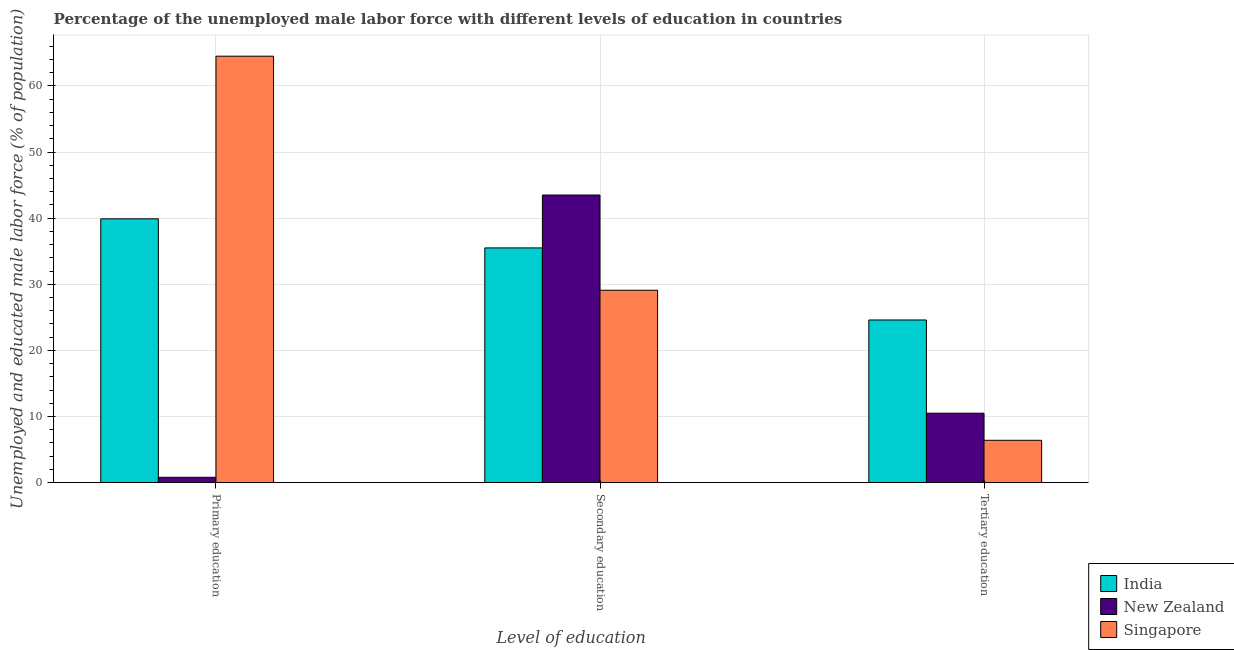How many groups of bars are there?
Provide a short and direct response. 3. Are the number of bars on each tick of the X-axis equal?
Ensure brevity in your answer.  Yes. How many bars are there on the 1st tick from the right?
Give a very brief answer. 3. What is the label of the 3rd group of bars from the left?
Your answer should be compact. Tertiary education. What is the percentage of male labor force who received primary education in New Zealand?
Provide a succinct answer. 0.8. Across all countries, what is the maximum percentage of male labor force who received secondary education?
Make the answer very short. 43.5. Across all countries, what is the minimum percentage of male labor force who received secondary education?
Ensure brevity in your answer.  29.1. In which country was the percentage of male labor force who received tertiary education maximum?
Give a very brief answer. India. In which country was the percentage of male labor force who received secondary education minimum?
Offer a very short reply. Singapore. What is the total percentage of male labor force who received primary education in the graph?
Make the answer very short. 105.2. What is the difference between the percentage of male labor force who received primary education in India and that in Singapore?
Offer a terse response. -24.6. What is the difference between the percentage of male labor force who received tertiary education in India and the percentage of male labor force who received primary education in Singapore?
Provide a short and direct response. -39.9. What is the average percentage of male labor force who received tertiary education per country?
Offer a very short reply. 13.83. What is the difference between the percentage of male labor force who received tertiary education and percentage of male labor force who received primary education in India?
Your answer should be very brief. -15.3. What is the ratio of the percentage of male labor force who received primary education in India to that in New Zealand?
Offer a terse response. 49.88. Is the difference between the percentage of male labor force who received secondary education in Singapore and New Zealand greater than the difference between the percentage of male labor force who received tertiary education in Singapore and New Zealand?
Your answer should be very brief. No. What is the difference between the highest and the second highest percentage of male labor force who received primary education?
Ensure brevity in your answer.  24.6. What is the difference between the highest and the lowest percentage of male labor force who received tertiary education?
Your answer should be compact. 18.2. In how many countries, is the percentage of male labor force who received tertiary education greater than the average percentage of male labor force who received tertiary education taken over all countries?
Offer a very short reply. 1. Is the sum of the percentage of male labor force who received secondary education in New Zealand and Singapore greater than the maximum percentage of male labor force who received primary education across all countries?
Your answer should be compact. Yes. What does the 3rd bar from the right in Secondary education represents?
Keep it short and to the point. India. How many bars are there?
Give a very brief answer. 9. Are all the bars in the graph horizontal?
Your answer should be compact. No. What is the difference between two consecutive major ticks on the Y-axis?
Offer a terse response. 10. Where does the legend appear in the graph?
Your response must be concise. Bottom right. How many legend labels are there?
Offer a very short reply. 3. How are the legend labels stacked?
Keep it short and to the point. Vertical. What is the title of the graph?
Your answer should be compact. Percentage of the unemployed male labor force with different levels of education in countries. What is the label or title of the X-axis?
Your answer should be very brief. Level of education. What is the label or title of the Y-axis?
Make the answer very short. Unemployed and educated male labor force (% of population). What is the Unemployed and educated male labor force (% of population) in India in Primary education?
Ensure brevity in your answer.  39.9. What is the Unemployed and educated male labor force (% of population) in New Zealand in Primary education?
Your answer should be compact. 0.8. What is the Unemployed and educated male labor force (% of population) of Singapore in Primary education?
Your answer should be very brief. 64.5. What is the Unemployed and educated male labor force (% of population) of India in Secondary education?
Your response must be concise. 35.5. What is the Unemployed and educated male labor force (% of population) of New Zealand in Secondary education?
Provide a succinct answer. 43.5. What is the Unemployed and educated male labor force (% of population) of Singapore in Secondary education?
Provide a short and direct response. 29.1. What is the Unemployed and educated male labor force (% of population) of India in Tertiary education?
Make the answer very short. 24.6. What is the Unemployed and educated male labor force (% of population) of New Zealand in Tertiary education?
Offer a terse response. 10.5. What is the Unemployed and educated male labor force (% of population) in Singapore in Tertiary education?
Your answer should be compact. 6.4. Across all Level of education, what is the maximum Unemployed and educated male labor force (% of population) in India?
Offer a very short reply. 39.9. Across all Level of education, what is the maximum Unemployed and educated male labor force (% of population) in New Zealand?
Offer a very short reply. 43.5. Across all Level of education, what is the maximum Unemployed and educated male labor force (% of population) of Singapore?
Your answer should be very brief. 64.5. Across all Level of education, what is the minimum Unemployed and educated male labor force (% of population) in India?
Offer a terse response. 24.6. Across all Level of education, what is the minimum Unemployed and educated male labor force (% of population) in New Zealand?
Your answer should be very brief. 0.8. Across all Level of education, what is the minimum Unemployed and educated male labor force (% of population) of Singapore?
Ensure brevity in your answer.  6.4. What is the total Unemployed and educated male labor force (% of population) of India in the graph?
Offer a terse response. 100. What is the total Unemployed and educated male labor force (% of population) of New Zealand in the graph?
Keep it short and to the point. 54.8. What is the difference between the Unemployed and educated male labor force (% of population) in India in Primary education and that in Secondary education?
Make the answer very short. 4.4. What is the difference between the Unemployed and educated male labor force (% of population) in New Zealand in Primary education and that in Secondary education?
Provide a short and direct response. -42.7. What is the difference between the Unemployed and educated male labor force (% of population) of Singapore in Primary education and that in Secondary education?
Offer a very short reply. 35.4. What is the difference between the Unemployed and educated male labor force (% of population) in India in Primary education and that in Tertiary education?
Offer a terse response. 15.3. What is the difference between the Unemployed and educated male labor force (% of population) in New Zealand in Primary education and that in Tertiary education?
Your answer should be very brief. -9.7. What is the difference between the Unemployed and educated male labor force (% of population) of Singapore in Primary education and that in Tertiary education?
Your answer should be compact. 58.1. What is the difference between the Unemployed and educated male labor force (% of population) in India in Secondary education and that in Tertiary education?
Provide a succinct answer. 10.9. What is the difference between the Unemployed and educated male labor force (% of population) of Singapore in Secondary education and that in Tertiary education?
Offer a very short reply. 22.7. What is the difference between the Unemployed and educated male labor force (% of population) of India in Primary education and the Unemployed and educated male labor force (% of population) of Singapore in Secondary education?
Your answer should be very brief. 10.8. What is the difference between the Unemployed and educated male labor force (% of population) in New Zealand in Primary education and the Unemployed and educated male labor force (% of population) in Singapore in Secondary education?
Keep it short and to the point. -28.3. What is the difference between the Unemployed and educated male labor force (% of population) of India in Primary education and the Unemployed and educated male labor force (% of population) of New Zealand in Tertiary education?
Ensure brevity in your answer.  29.4. What is the difference between the Unemployed and educated male labor force (% of population) in India in Primary education and the Unemployed and educated male labor force (% of population) in Singapore in Tertiary education?
Provide a succinct answer. 33.5. What is the difference between the Unemployed and educated male labor force (% of population) in India in Secondary education and the Unemployed and educated male labor force (% of population) in New Zealand in Tertiary education?
Ensure brevity in your answer.  25. What is the difference between the Unemployed and educated male labor force (% of population) in India in Secondary education and the Unemployed and educated male labor force (% of population) in Singapore in Tertiary education?
Your response must be concise. 29.1. What is the difference between the Unemployed and educated male labor force (% of population) of New Zealand in Secondary education and the Unemployed and educated male labor force (% of population) of Singapore in Tertiary education?
Offer a very short reply. 37.1. What is the average Unemployed and educated male labor force (% of population) of India per Level of education?
Your answer should be compact. 33.33. What is the average Unemployed and educated male labor force (% of population) in New Zealand per Level of education?
Your answer should be very brief. 18.27. What is the average Unemployed and educated male labor force (% of population) of Singapore per Level of education?
Offer a very short reply. 33.33. What is the difference between the Unemployed and educated male labor force (% of population) in India and Unemployed and educated male labor force (% of population) in New Zealand in Primary education?
Keep it short and to the point. 39.1. What is the difference between the Unemployed and educated male labor force (% of population) in India and Unemployed and educated male labor force (% of population) in Singapore in Primary education?
Offer a terse response. -24.6. What is the difference between the Unemployed and educated male labor force (% of population) in New Zealand and Unemployed and educated male labor force (% of population) in Singapore in Primary education?
Your answer should be compact. -63.7. What is the difference between the Unemployed and educated male labor force (% of population) of India and Unemployed and educated male labor force (% of population) of New Zealand in Tertiary education?
Your answer should be very brief. 14.1. What is the difference between the Unemployed and educated male labor force (% of population) of New Zealand and Unemployed and educated male labor force (% of population) of Singapore in Tertiary education?
Provide a succinct answer. 4.1. What is the ratio of the Unemployed and educated male labor force (% of population) in India in Primary education to that in Secondary education?
Your answer should be very brief. 1.12. What is the ratio of the Unemployed and educated male labor force (% of population) of New Zealand in Primary education to that in Secondary education?
Offer a very short reply. 0.02. What is the ratio of the Unemployed and educated male labor force (% of population) of Singapore in Primary education to that in Secondary education?
Give a very brief answer. 2.22. What is the ratio of the Unemployed and educated male labor force (% of population) of India in Primary education to that in Tertiary education?
Your response must be concise. 1.62. What is the ratio of the Unemployed and educated male labor force (% of population) in New Zealand in Primary education to that in Tertiary education?
Provide a succinct answer. 0.08. What is the ratio of the Unemployed and educated male labor force (% of population) of Singapore in Primary education to that in Tertiary education?
Offer a terse response. 10.08. What is the ratio of the Unemployed and educated male labor force (% of population) in India in Secondary education to that in Tertiary education?
Ensure brevity in your answer.  1.44. What is the ratio of the Unemployed and educated male labor force (% of population) of New Zealand in Secondary education to that in Tertiary education?
Offer a very short reply. 4.14. What is the ratio of the Unemployed and educated male labor force (% of population) of Singapore in Secondary education to that in Tertiary education?
Your response must be concise. 4.55. What is the difference between the highest and the second highest Unemployed and educated male labor force (% of population) of India?
Make the answer very short. 4.4. What is the difference between the highest and the second highest Unemployed and educated male labor force (% of population) in New Zealand?
Ensure brevity in your answer.  33. What is the difference between the highest and the second highest Unemployed and educated male labor force (% of population) of Singapore?
Give a very brief answer. 35.4. What is the difference between the highest and the lowest Unemployed and educated male labor force (% of population) in New Zealand?
Offer a very short reply. 42.7. What is the difference between the highest and the lowest Unemployed and educated male labor force (% of population) in Singapore?
Your answer should be compact. 58.1. 